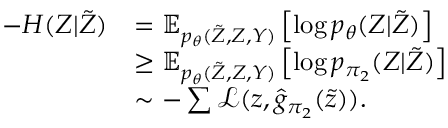<formula> <loc_0><loc_0><loc_500><loc_500>\begin{array} { r l } { - H ( Z | \tilde { Z } ) } & { = \mathbb { E } _ { p _ { \theta } ( \tilde { Z } , Z , Y ) } \left [ \log p _ { \theta } ( Z | \tilde { Z } ) \right ] } \\ & { \geq \mathbb { E } _ { p _ { \theta } ( \tilde { Z } , Z , Y ) } \left [ \log p _ { { \pi _ { 2 } } } ( Z | \tilde { Z } ) \right ] } \\ & { \sim - \sum \mathcal { L } ( z , \hat { g } _ { \pi _ { 2 } } ( \tilde { z } ) ) . } \end{array}</formula> 